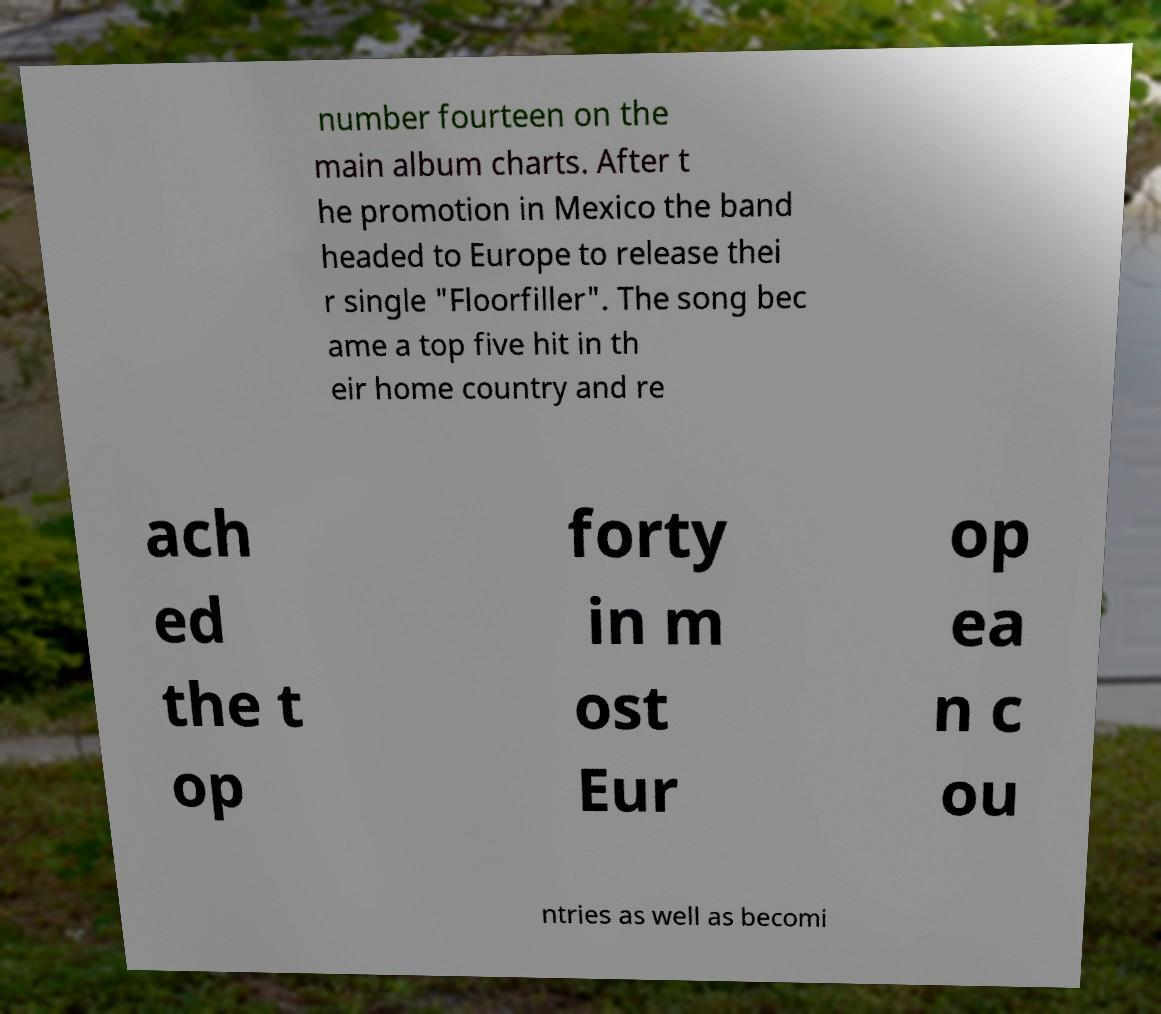There's text embedded in this image that I need extracted. Can you transcribe it verbatim? number fourteen on the main album charts. After t he promotion in Mexico the band headed to Europe to release thei r single "Floorfiller". The song bec ame a top five hit in th eir home country and re ach ed the t op forty in m ost Eur op ea n c ou ntries as well as becomi 